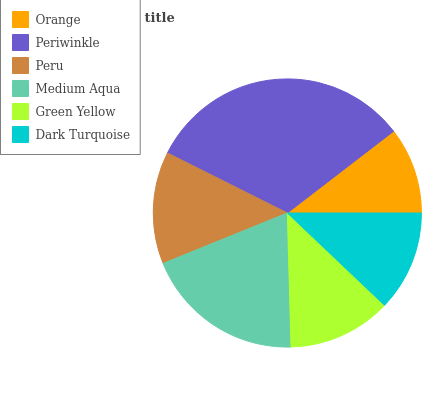Is Orange the minimum?
Answer yes or no. Yes. Is Periwinkle the maximum?
Answer yes or no. Yes. Is Peru the minimum?
Answer yes or no. No. Is Peru the maximum?
Answer yes or no. No. Is Periwinkle greater than Peru?
Answer yes or no. Yes. Is Peru less than Periwinkle?
Answer yes or no. Yes. Is Peru greater than Periwinkle?
Answer yes or no. No. Is Periwinkle less than Peru?
Answer yes or no. No. Is Peru the high median?
Answer yes or no. Yes. Is Green Yellow the low median?
Answer yes or no. Yes. Is Green Yellow the high median?
Answer yes or no. No. Is Peru the low median?
Answer yes or no. No. 